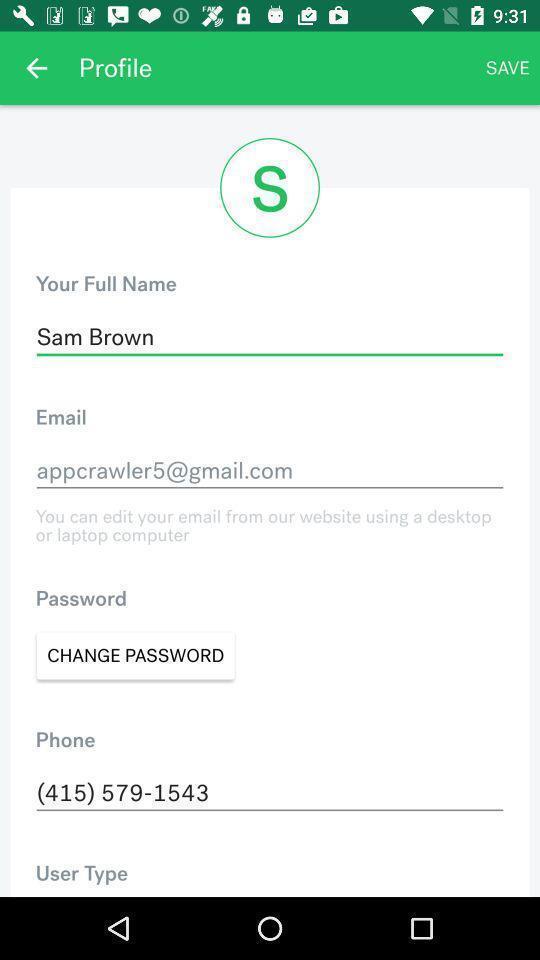Describe this image in words. Profile page. 